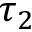<formula> <loc_0><loc_0><loc_500><loc_500>\tau _ { 2 }</formula> 